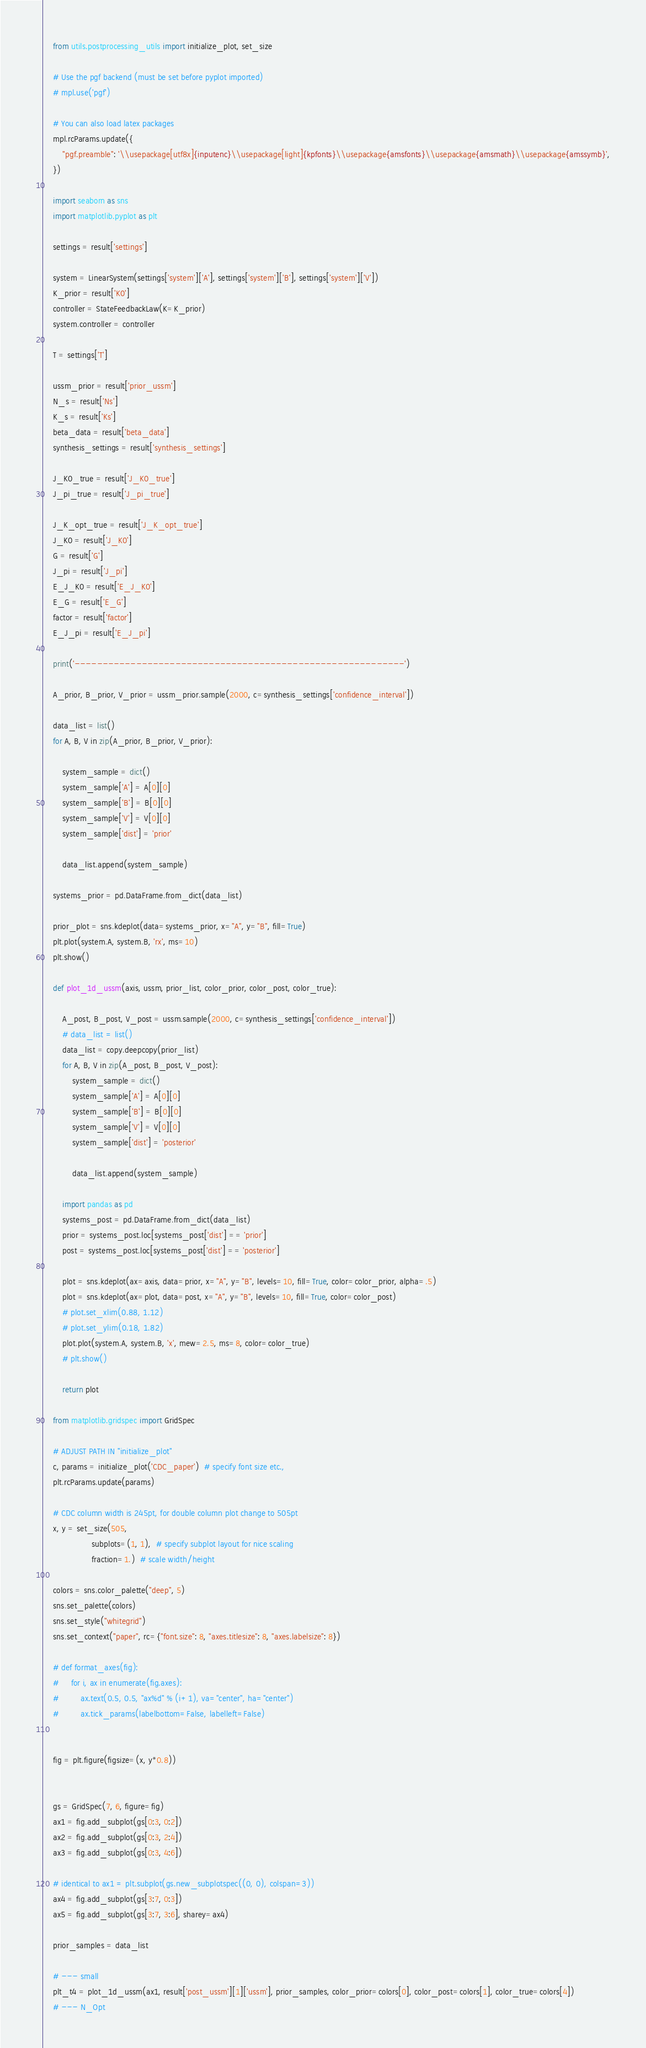<code> <loc_0><loc_0><loc_500><loc_500><_Python_>    from utils.postprocessing_utils import initialize_plot, set_size

    # Use the pgf backend (must be set before pyplot imported)
    # mpl.use('pgf')

    # You can also load latex packages
    mpl.rcParams.update({
        "pgf.preamble": '\\usepackage[utf8x]{inputenc}\\usepackage[light]{kpfonts}\\usepackage{amsfonts}\\usepackage{amsmath}\\usepackage{amssymb}',
    })

    import seaborn as sns
    import matplotlib.pyplot as plt

    settings = result['settings']

    system = LinearSystem(settings['system']['A'], settings['system']['B'], settings['system']['V'])
    K_prior = result['K0']
    controller = StateFeedbackLaw(K=K_prior)
    system.controller = controller

    T = settings['T']

    ussm_prior = result['prior_ussm']
    N_s = result['Ns']
    K_s = result['Ks']
    beta_data = result['beta_data']
    synthesis_settings = result['synthesis_settings']

    J_K0_true = result['J_K0_true']
    J_pi_true = result['J_pi_true']

    J_K_opt_true = result['J_K_opt_true']
    J_K0 = result['J_K0']
    G = result['G']
    J_pi = result['J_pi']
    E_J_K0 = result['E_J_K0']
    E_G = result['E_G']
    factor = result['factor']
    E_J_pi = result['E_J_pi']

    print('-----------------------------------------------------------')

    A_prior, B_prior, V_prior = ussm_prior.sample(2000, c=synthesis_settings['confidence_interval'])

    data_list = list()
    for A, B, V in zip(A_prior, B_prior, V_prior):

        system_sample = dict()
        system_sample['A'] = A[0][0]
        system_sample['B'] = B[0][0]
        system_sample['V'] = V[0][0]
        system_sample['dist'] = 'prior'

        data_list.append(system_sample)

    systems_prior = pd.DataFrame.from_dict(data_list)

    prior_plot = sns.kdeplot(data=systems_prior, x="A", y="B", fill=True)
    plt.plot(system.A, system.B, 'rx', ms=10)
    plt.show()

    def plot_1d_ussm(axis, ussm, prior_list, color_prior, color_post, color_true):

        A_post, B_post, V_post = ussm.sample(2000, c=synthesis_settings['confidence_interval'])
        # data_list = list()
        data_list = copy.deepcopy(prior_list)
        for A, B, V in zip(A_post, B_post, V_post):
            system_sample = dict()
            system_sample['A'] = A[0][0]
            system_sample['B'] = B[0][0]
            system_sample['V'] = V[0][0]
            system_sample['dist'] = 'posterior'

            data_list.append(system_sample)

        import pandas as pd
        systems_post = pd.DataFrame.from_dict(data_list)
        prior = systems_post.loc[systems_post['dist'] == 'prior']
        post = systems_post.loc[systems_post['dist'] == 'posterior']

        plot = sns.kdeplot(ax=axis, data=prior, x="A", y="B", levels=10, fill=True, color=color_prior, alpha=.5)
        plot = sns.kdeplot(ax=plot, data=post, x="A", y="B", levels=10, fill=True, color=color_post)
        # plot.set_xlim(0.88, 1.12)
        # plot.set_ylim(0.18, 1.82)
        plot.plot(system.A, system.B, 'x', mew=2.5, ms=8, color=color_true)
        # plt.show()

        return plot

    from matplotlib.gridspec import GridSpec

    # ADJUST PATH IN "initialize_plot"
    c, params = initialize_plot('CDC_paper')  # specify font size etc.,
    plt.rcParams.update(params)

    # CDC column width is 245pt, for double column plot change to 505pt
    x, y = set_size(505,
                    subplots=(1, 1),  # specify subplot layout for nice scaling
                    fraction=1.)  # scale width/height

    colors = sns.color_palette("deep", 5)
    sns.set_palette(colors)
    sns.set_style("whitegrid")
    sns.set_context("paper", rc={"font.size": 8, "axes.titlesize": 8, "axes.labelsize": 8})

    # def format_axes(fig):
    #     for i, ax in enumerate(fig.axes):
    #         ax.text(0.5, 0.5, "ax%d" % (i+1), va="center", ha="center")
    #         ax.tick_params(labelbottom=False, labelleft=False)


    fig = plt.figure(figsize=(x, y*0.8))


    gs = GridSpec(7, 6, figure=fig)
    ax1 = fig.add_subplot(gs[0:3, 0:2])
    ax2 = fig.add_subplot(gs[0:3, 2:4])
    ax3 = fig.add_subplot(gs[0:3, 4:6])

    # identical to ax1 = plt.subplot(gs.new_subplotspec((0, 0), colspan=3))
    ax4 = fig.add_subplot(gs[3:7, 0:3])
    ax5 = fig.add_subplot(gs[3:7, 3:6], sharey=ax4)

    prior_samples = data_list

    # --- small
    plt_t4 = plot_1d_ussm(ax1, result['post_ussm'][1]['ussm'], prior_samples, color_prior=colors[0], color_post=colors[1], color_true=colors[4])
    # --- N_Opt</code> 